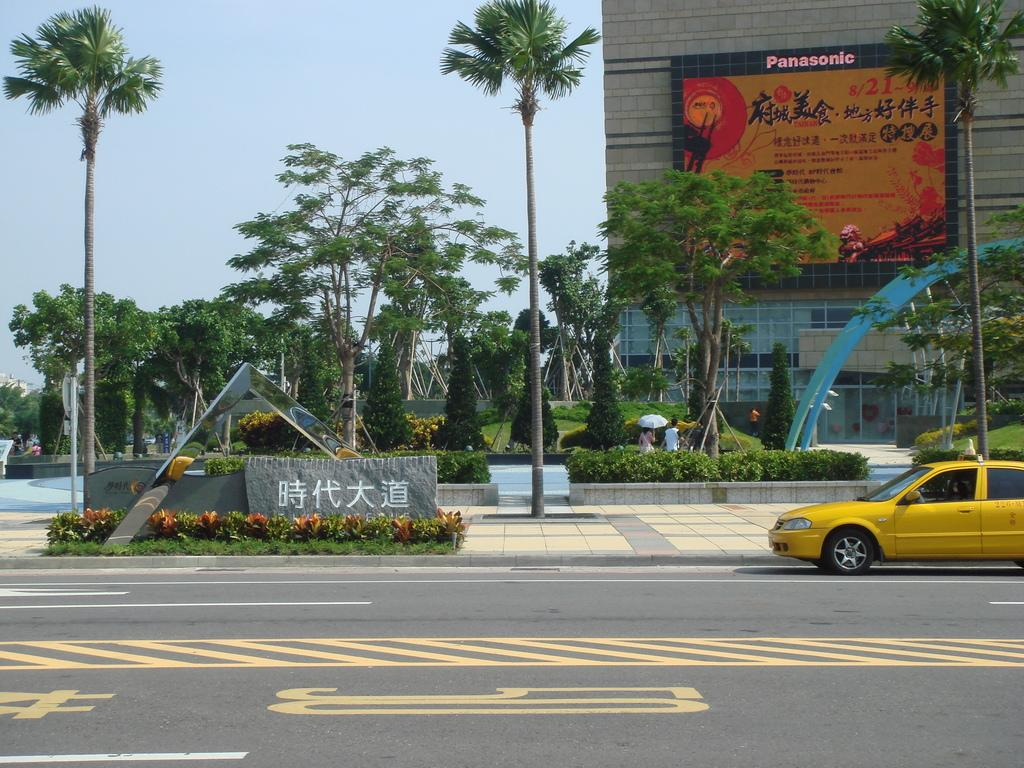<image>
Offer a succinct explanation of the picture presented. a building that has the word Panasonic on it 